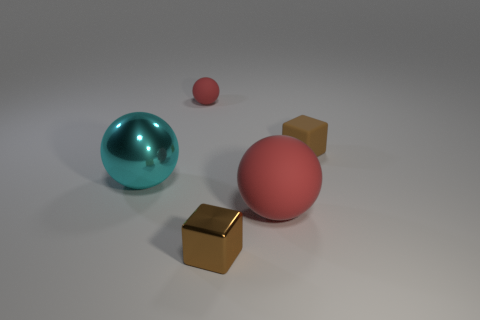There is another brown object that is the same shape as the tiny brown rubber object; what size is it?
Offer a very short reply. Small. Is there any other thing that has the same size as the cyan shiny ball?
Give a very brief answer. Yes. Is the tiny cube that is right of the tiny metallic object made of the same material as the small red ball?
Your response must be concise. Yes. There is another rubber thing that is the same shape as the tiny red object; what is its color?
Offer a terse response. Red. What number of other objects are the same color as the metal ball?
Ensure brevity in your answer.  0. Do the large object in front of the large cyan object and the brown thing to the right of the big matte object have the same shape?
Provide a succinct answer. No. What number of cylinders are brown rubber objects or large cyan metal objects?
Offer a terse response. 0. Are there fewer cyan things left of the cyan thing than spheres?
Offer a terse response. Yes. How many other things are there of the same material as the large cyan thing?
Ensure brevity in your answer.  1. Do the brown metal object and the cyan metal sphere have the same size?
Make the answer very short. No. 